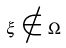Convert formula to latex. <formula><loc_0><loc_0><loc_500><loc_500>\xi \notin \Omega</formula> 